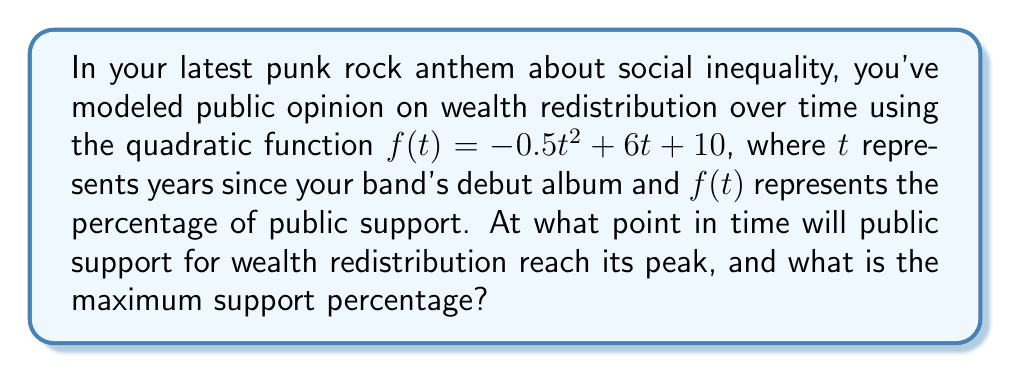Help me with this question. To find the vertex of this parabola, we'll follow these steps:

1) The general form of a quadratic function is $f(t) = at^2 + bt + c$, where $a = -0.5$, $b = 6$, and $c = 10$.

2) For a parabola, the t-coordinate of the vertex is given by the formula $t = -\frac{b}{2a}$.

3) Substituting our values:
   $t = -\frac{6}{2(-0.5)} = -\frac{6}{-1} = 6$

4) To find the maximum support percentage, we substitute this t-value back into our original function:

   $f(6) = -0.5(6)^2 + 6(6) + 10$
   $= -0.5(36) + 36 + 10$
   $= -18 + 36 + 10$
   $= 28$

5) Therefore, the vertex of the parabola is at the point (6, 28).

This means public support for wealth redistribution will peak 6 years after your band's debut album, reaching a maximum of 28% support.
Answer: (6, 28) 